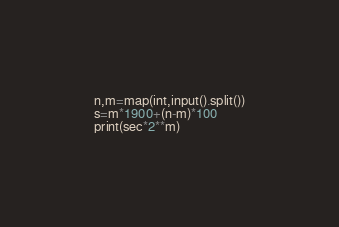Convert code to text. <code><loc_0><loc_0><loc_500><loc_500><_Python_>n,m=map(int,input().split())
s=m*1900+(n-m)*100
print(sec*2**m)</code> 